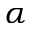Convert formula to latex. <formula><loc_0><loc_0><loc_500><loc_500>\alpha</formula> 